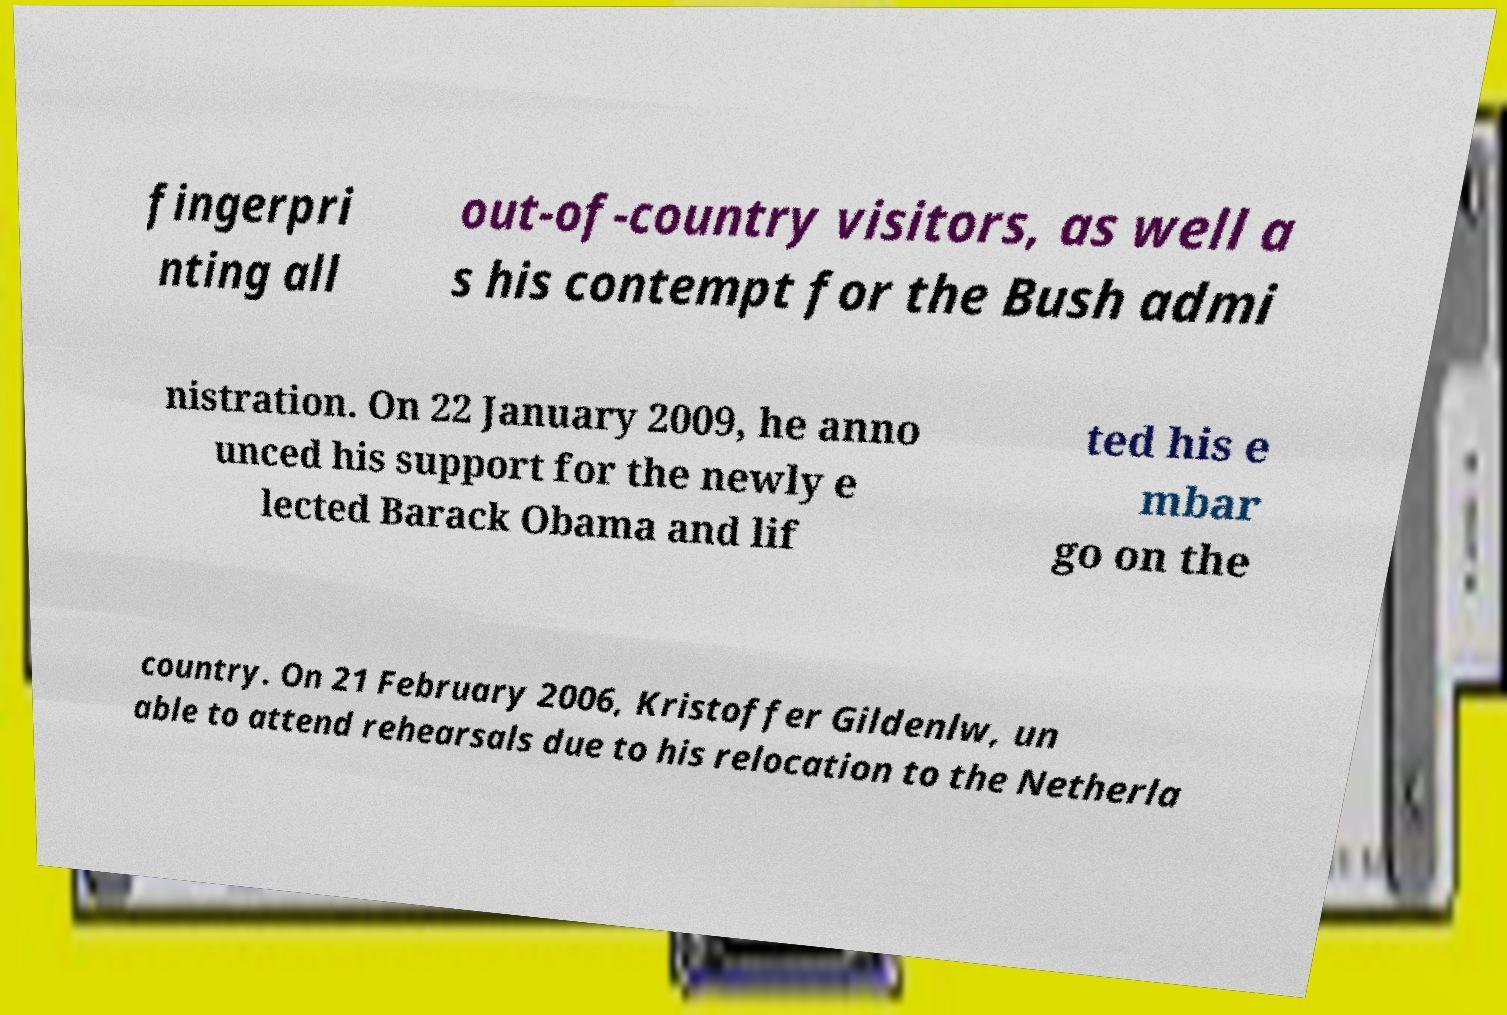Please read and relay the text visible in this image. What does it say? fingerpri nting all out-of-country visitors, as well a s his contempt for the Bush admi nistration. On 22 January 2009, he anno unced his support for the newly e lected Barack Obama and lif ted his e mbar go on the country. On 21 February 2006, Kristoffer Gildenlw, un able to attend rehearsals due to his relocation to the Netherla 